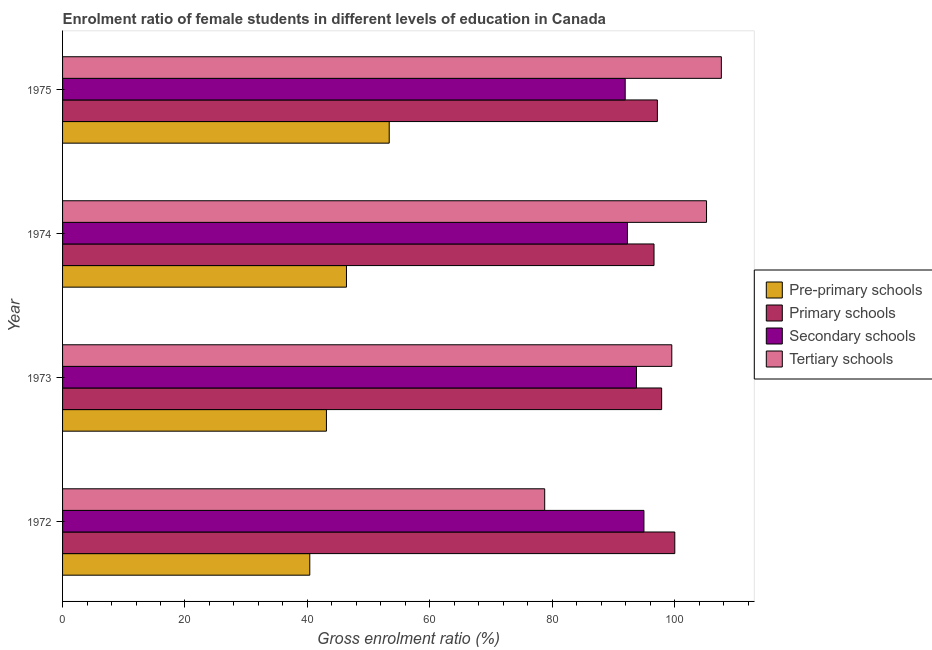Are the number of bars on each tick of the Y-axis equal?
Keep it short and to the point. Yes. How many bars are there on the 4th tick from the bottom?
Keep it short and to the point. 4. What is the label of the 1st group of bars from the top?
Provide a short and direct response. 1975. What is the gross enrolment ratio(male) in pre-primary schools in 1975?
Make the answer very short. 53.37. Across all years, what is the maximum gross enrolment ratio(male) in pre-primary schools?
Ensure brevity in your answer.  53.37. Across all years, what is the minimum gross enrolment ratio(male) in pre-primary schools?
Give a very brief answer. 40.39. In which year was the gross enrolment ratio(male) in tertiary schools maximum?
Offer a terse response. 1975. What is the total gross enrolment ratio(male) in primary schools in the graph?
Give a very brief answer. 391.71. What is the difference between the gross enrolment ratio(male) in primary schools in 1974 and that in 1975?
Ensure brevity in your answer.  -0.55. What is the difference between the gross enrolment ratio(male) in tertiary schools in 1972 and the gross enrolment ratio(male) in secondary schools in 1975?
Give a very brief answer. -13.15. What is the average gross enrolment ratio(male) in pre-primary schools per year?
Provide a short and direct response. 45.81. In the year 1974, what is the difference between the gross enrolment ratio(male) in tertiary schools and gross enrolment ratio(male) in pre-primary schools?
Make the answer very short. 58.83. What is the ratio of the gross enrolment ratio(male) in tertiary schools in 1972 to that in 1974?
Give a very brief answer. 0.75. Is the gross enrolment ratio(male) in secondary schools in 1972 less than that in 1973?
Give a very brief answer. No. Is the difference between the gross enrolment ratio(male) in tertiary schools in 1973 and 1974 greater than the difference between the gross enrolment ratio(male) in pre-primary schools in 1973 and 1974?
Provide a short and direct response. No. What is the difference between the highest and the second highest gross enrolment ratio(male) in primary schools?
Your answer should be very brief. 2.15. What is the difference between the highest and the lowest gross enrolment ratio(male) in primary schools?
Your answer should be compact. 3.39. In how many years, is the gross enrolment ratio(male) in pre-primary schools greater than the average gross enrolment ratio(male) in pre-primary schools taken over all years?
Make the answer very short. 2. Is it the case that in every year, the sum of the gross enrolment ratio(male) in pre-primary schools and gross enrolment ratio(male) in primary schools is greater than the sum of gross enrolment ratio(male) in tertiary schools and gross enrolment ratio(male) in secondary schools?
Make the answer very short. Yes. What does the 4th bar from the top in 1974 represents?
Your response must be concise. Pre-primary schools. What does the 3rd bar from the bottom in 1974 represents?
Your answer should be very brief. Secondary schools. Is it the case that in every year, the sum of the gross enrolment ratio(male) in pre-primary schools and gross enrolment ratio(male) in primary schools is greater than the gross enrolment ratio(male) in secondary schools?
Your response must be concise. Yes. How many years are there in the graph?
Your answer should be compact. 4. Are the values on the major ticks of X-axis written in scientific E-notation?
Your answer should be very brief. No. Does the graph contain any zero values?
Your answer should be very brief. No. Where does the legend appear in the graph?
Provide a short and direct response. Center right. How many legend labels are there?
Ensure brevity in your answer.  4. What is the title of the graph?
Ensure brevity in your answer.  Enrolment ratio of female students in different levels of education in Canada. Does "Minerals" appear as one of the legend labels in the graph?
Your answer should be very brief. No. What is the label or title of the X-axis?
Give a very brief answer. Gross enrolment ratio (%). What is the Gross enrolment ratio (%) in Pre-primary schools in 1972?
Make the answer very short. 40.39. What is the Gross enrolment ratio (%) of Primary schools in 1972?
Keep it short and to the point. 100.02. What is the Gross enrolment ratio (%) of Secondary schools in 1972?
Provide a succinct answer. 94.98. What is the Gross enrolment ratio (%) of Tertiary schools in 1972?
Provide a short and direct response. 78.77. What is the Gross enrolment ratio (%) of Pre-primary schools in 1973?
Give a very brief answer. 43.11. What is the Gross enrolment ratio (%) of Primary schools in 1973?
Ensure brevity in your answer.  97.88. What is the Gross enrolment ratio (%) in Secondary schools in 1973?
Make the answer very short. 93.76. What is the Gross enrolment ratio (%) of Tertiary schools in 1973?
Your response must be concise. 99.53. What is the Gross enrolment ratio (%) in Pre-primary schools in 1974?
Offer a very short reply. 46.38. What is the Gross enrolment ratio (%) of Primary schools in 1974?
Your answer should be compact. 96.63. What is the Gross enrolment ratio (%) in Secondary schools in 1974?
Your answer should be compact. 92.28. What is the Gross enrolment ratio (%) in Tertiary schools in 1974?
Offer a very short reply. 105.21. What is the Gross enrolment ratio (%) in Pre-primary schools in 1975?
Make the answer very short. 53.37. What is the Gross enrolment ratio (%) in Primary schools in 1975?
Your answer should be very brief. 97.18. What is the Gross enrolment ratio (%) in Secondary schools in 1975?
Your answer should be compact. 91.92. What is the Gross enrolment ratio (%) of Tertiary schools in 1975?
Provide a succinct answer. 107.63. Across all years, what is the maximum Gross enrolment ratio (%) of Pre-primary schools?
Provide a short and direct response. 53.37. Across all years, what is the maximum Gross enrolment ratio (%) of Primary schools?
Provide a succinct answer. 100.02. Across all years, what is the maximum Gross enrolment ratio (%) of Secondary schools?
Provide a short and direct response. 94.98. Across all years, what is the maximum Gross enrolment ratio (%) in Tertiary schools?
Keep it short and to the point. 107.63. Across all years, what is the minimum Gross enrolment ratio (%) in Pre-primary schools?
Your answer should be very brief. 40.39. Across all years, what is the minimum Gross enrolment ratio (%) in Primary schools?
Ensure brevity in your answer.  96.63. Across all years, what is the minimum Gross enrolment ratio (%) in Secondary schools?
Ensure brevity in your answer.  91.92. Across all years, what is the minimum Gross enrolment ratio (%) in Tertiary schools?
Give a very brief answer. 78.77. What is the total Gross enrolment ratio (%) in Pre-primary schools in the graph?
Provide a short and direct response. 183.25. What is the total Gross enrolment ratio (%) of Primary schools in the graph?
Make the answer very short. 391.71. What is the total Gross enrolment ratio (%) in Secondary schools in the graph?
Keep it short and to the point. 372.95. What is the total Gross enrolment ratio (%) of Tertiary schools in the graph?
Keep it short and to the point. 391.14. What is the difference between the Gross enrolment ratio (%) of Pre-primary schools in 1972 and that in 1973?
Offer a terse response. -2.72. What is the difference between the Gross enrolment ratio (%) of Primary schools in 1972 and that in 1973?
Keep it short and to the point. 2.15. What is the difference between the Gross enrolment ratio (%) of Secondary schools in 1972 and that in 1973?
Provide a short and direct response. 1.22. What is the difference between the Gross enrolment ratio (%) of Tertiary schools in 1972 and that in 1973?
Your answer should be very brief. -20.76. What is the difference between the Gross enrolment ratio (%) in Pre-primary schools in 1972 and that in 1974?
Keep it short and to the point. -5.99. What is the difference between the Gross enrolment ratio (%) of Primary schools in 1972 and that in 1974?
Your answer should be very brief. 3.39. What is the difference between the Gross enrolment ratio (%) of Secondary schools in 1972 and that in 1974?
Offer a terse response. 2.7. What is the difference between the Gross enrolment ratio (%) in Tertiary schools in 1972 and that in 1974?
Your answer should be compact. -26.44. What is the difference between the Gross enrolment ratio (%) of Pre-primary schools in 1972 and that in 1975?
Keep it short and to the point. -12.98. What is the difference between the Gross enrolment ratio (%) in Primary schools in 1972 and that in 1975?
Provide a succinct answer. 2.85. What is the difference between the Gross enrolment ratio (%) of Secondary schools in 1972 and that in 1975?
Provide a succinct answer. 3.06. What is the difference between the Gross enrolment ratio (%) in Tertiary schools in 1972 and that in 1975?
Your response must be concise. -28.86. What is the difference between the Gross enrolment ratio (%) in Pre-primary schools in 1973 and that in 1974?
Make the answer very short. -3.27. What is the difference between the Gross enrolment ratio (%) in Primary schools in 1973 and that in 1974?
Offer a terse response. 1.25. What is the difference between the Gross enrolment ratio (%) of Secondary schools in 1973 and that in 1974?
Provide a succinct answer. 1.48. What is the difference between the Gross enrolment ratio (%) in Tertiary schools in 1973 and that in 1974?
Ensure brevity in your answer.  -5.68. What is the difference between the Gross enrolment ratio (%) in Pre-primary schools in 1973 and that in 1975?
Ensure brevity in your answer.  -10.26. What is the difference between the Gross enrolment ratio (%) in Primary schools in 1973 and that in 1975?
Keep it short and to the point. 0.7. What is the difference between the Gross enrolment ratio (%) of Secondary schools in 1973 and that in 1975?
Make the answer very short. 1.84. What is the difference between the Gross enrolment ratio (%) in Tertiary schools in 1973 and that in 1975?
Keep it short and to the point. -8.1. What is the difference between the Gross enrolment ratio (%) in Pre-primary schools in 1974 and that in 1975?
Your answer should be very brief. -6.98. What is the difference between the Gross enrolment ratio (%) in Primary schools in 1974 and that in 1975?
Make the answer very short. -0.55. What is the difference between the Gross enrolment ratio (%) of Secondary schools in 1974 and that in 1975?
Ensure brevity in your answer.  0.36. What is the difference between the Gross enrolment ratio (%) of Tertiary schools in 1974 and that in 1975?
Make the answer very short. -2.42. What is the difference between the Gross enrolment ratio (%) in Pre-primary schools in 1972 and the Gross enrolment ratio (%) in Primary schools in 1973?
Your response must be concise. -57.49. What is the difference between the Gross enrolment ratio (%) in Pre-primary schools in 1972 and the Gross enrolment ratio (%) in Secondary schools in 1973?
Give a very brief answer. -53.37. What is the difference between the Gross enrolment ratio (%) of Pre-primary schools in 1972 and the Gross enrolment ratio (%) of Tertiary schools in 1973?
Offer a very short reply. -59.14. What is the difference between the Gross enrolment ratio (%) of Primary schools in 1972 and the Gross enrolment ratio (%) of Secondary schools in 1973?
Offer a terse response. 6.26. What is the difference between the Gross enrolment ratio (%) of Primary schools in 1972 and the Gross enrolment ratio (%) of Tertiary schools in 1973?
Ensure brevity in your answer.  0.49. What is the difference between the Gross enrolment ratio (%) of Secondary schools in 1972 and the Gross enrolment ratio (%) of Tertiary schools in 1973?
Offer a terse response. -4.55. What is the difference between the Gross enrolment ratio (%) in Pre-primary schools in 1972 and the Gross enrolment ratio (%) in Primary schools in 1974?
Offer a very short reply. -56.24. What is the difference between the Gross enrolment ratio (%) of Pre-primary schools in 1972 and the Gross enrolment ratio (%) of Secondary schools in 1974?
Offer a very short reply. -51.89. What is the difference between the Gross enrolment ratio (%) of Pre-primary schools in 1972 and the Gross enrolment ratio (%) of Tertiary schools in 1974?
Your response must be concise. -64.82. What is the difference between the Gross enrolment ratio (%) in Primary schools in 1972 and the Gross enrolment ratio (%) in Secondary schools in 1974?
Keep it short and to the point. 7.74. What is the difference between the Gross enrolment ratio (%) of Primary schools in 1972 and the Gross enrolment ratio (%) of Tertiary schools in 1974?
Offer a terse response. -5.18. What is the difference between the Gross enrolment ratio (%) of Secondary schools in 1972 and the Gross enrolment ratio (%) of Tertiary schools in 1974?
Your response must be concise. -10.23. What is the difference between the Gross enrolment ratio (%) in Pre-primary schools in 1972 and the Gross enrolment ratio (%) in Primary schools in 1975?
Keep it short and to the point. -56.79. What is the difference between the Gross enrolment ratio (%) in Pre-primary schools in 1972 and the Gross enrolment ratio (%) in Secondary schools in 1975?
Your answer should be compact. -51.53. What is the difference between the Gross enrolment ratio (%) of Pre-primary schools in 1972 and the Gross enrolment ratio (%) of Tertiary schools in 1975?
Provide a short and direct response. -67.24. What is the difference between the Gross enrolment ratio (%) in Primary schools in 1972 and the Gross enrolment ratio (%) in Secondary schools in 1975?
Offer a very short reply. 8.1. What is the difference between the Gross enrolment ratio (%) of Primary schools in 1972 and the Gross enrolment ratio (%) of Tertiary schools in 1975?
Keep it short and to the point. -7.61. What is the difference between the Gross enrolment ratio (%) of Secondary schools in 1972 and the Gross enrolment ratio (%) of Tertiary schools in 1975?
Your answer should be very brief. -12.65. What is the difference between the Gross enrolment ratio (%) of Pre-primary schools in 1973 and the Gross enrolment ratio (%) of Primary schools in 1974?
Your answer should be very brief. -53.52. What is the difference between the Gross enrolment ratio (%) of Pre-primary schools in 1973 and the Gross enrolment ratio (%) of Secondary schools in 1974?
Make the answer very short. -49.17. What is the difference between the Gross enrolment ratio (%) of Pre-primary schools in 1973 and the Gross enrolment ratio (%) of Tertiary schools in 1974?
Your answer should be very brief. -62.1. What is the difference between the Gross enrolment ratio (%) of Primary schools in 1973 and the Gross enrolment ratio (%) of Secondary schools in 1974?
Ensure brevity in your answer.  5.59. What is the difference between the Gross enrolment ratio (%) in Primary schools in 1973 and the Gross enrolment ratio (%) in Tertiary schools in 1974?
Your answer should be very brief. -7.33. What is the difference between the Gross enrolment ratio (%) in Secondary schools in 1973 and the Gross enrolment ratio (%) in Tertiary schools in 1974?
Your response must be concise. -11.45. What is the difference between the Gross enrolment ratio (%) in Pre-primary schools in 1973 and the Gross enrolment ratio (%) in Primary schools in 1975?
Provide a short and direct response. -54.07. What is the difference between the Gross enrolment ratio (%) in Pre-primary schools in 1973 and the Gross enrolment ratio (%) in Secondary schools in 1975?
Your answer should be compact. -48.81. What is the difference between the Gross enrolment ratio (%) in Pre-primary schools in 1973 and the Gross enrolment ratio (%) in Tertiary schools in 1975?
Offer a terse response. -64.52. What is the difference between the Gross enrolment ratio (%) in Primary schools in 1973 and the Gross enrolment ratio (%) in Secondary schools in 1975?
Offer a terse response. 5.95. What is the difference between the Gross enrolment ratio (%) of Primary schools in 1973 and the Gross enrolment ratio (%) of Tertiary schools in 1975?
Ensure brevity in your answer.  -9.75. What is the difference between the Gross enrolment ratio (%) of Secondary schools in 1973 and the Gross enrolment ratio (%) of Tertiary schools in 1975?
Ensure brevity in your answer.  -13.87. What is the difference between the Gross enrolment ratio (%) of Pre-primary schools in 1974 and the Gross enrolment ratio (%) of Primary schools in 1975?
Your answer should be very brief. -50.79. What is the difference between the Gross enrolment ratio (%) in Pre-primary schools in 1974 and the Gross enrolment ratio (%) in Secondary schools in 1975?
Provide a short and direct response. -45.54. What is the difference between the Gross enrolment ratio (%) of Pre-primary schools in 1974 and the Gross enrolment ratio (%) of Tertiary schools in 1975?
Your answer should be compact. -61.25. What is the difference between the Gross enrolment ratio (%) of Primary schools in 1974 and the Gross enrolment ratio (%) of Secondary schools in 1975?
Your answer should be very brief. 4.71. What is the difference between the Gross enrolment ratio (%) in Primary schools in 1974 and the Gross enrolment ratio (%) in Tertiary schools in 1975?
Make the answer very short. -11. What is the difference between the Gross enrolment ratio (%) of Secondary schools in 1974 and the Gross enrolment ratio (%) of Tertiary schools in 1975?
Offer a very short reply. -15.35. What is the average Gross enrolment ratio (%) in Pre-primary schools per year?
Your answer should be compact. 45.81. What is the average Gross enrolment ratio (%) of Primary schools per year?
Provide a succinct answer. 97.93. What is the average Gross enrolment ratio (%) of Secondary schools per year?
Offer a very short reply. 93.24. What is the average Gross enrolment ratio (%) of Tertiary schools per year?
Your answer should be very brief. 97.79. In the year 1972, what is the difference between the Gross enrolment ratio (%) in Pre-primary schools and Gross enrolment ratio (%) in Primary schools?
Give a very brief answer. -59.63. In the year 1972, what is the difference between the Gross enrolment ratio (%) in Pre-primary schools and Gross enrolment ratio (%) in Secondary schools?
Offer a terse response. -54.59. In the year 1972, what is the difference between the Gross enrolment ratio (%) of Pre-primary schools and Gross enrolment ratio (%) of Tertiary schools?
Give a very brief answer. -38.38. In the year 1972, what is the difference between the Gross enrolment ratio (%) in Primary schools and Gross enrolment ratio (%) in Secondary schools?
Offer a very short reply. 5.04. In the year 1972, what is the difference between the Gross enrolment ratio (%) in Primary schools and Gross enrolment ratio (%) in Tertiary schools?
Offer a very short reply. 21.26. In the year 1972, what is the difference between the Gross enrolment ratio (%) of Secondary schools and Gross enrolment ratio (%) of Tertiary schools?
Offer a very short reply. 16.21. In the year 1973, what is the difference between the Gross enrolment ratio (%) in Pre-primary schools and Gross enrolment ratio (%) in Primary schools?
Make the answer very short. -54.77. In the year 1973, what is the difference between the Gross enrolment ratio (%) of Pre-primary schools and Gross enrolment ratio (%) of Secondary schools?
Offer a very short reply. -50.65. In the year 1973, what is the difference between the Gross enrolment ratio (%) in Pre-primary schools and Gross enrolment ratio (%) in Tertiary schools?
Ensure brevity in your answer.  -56.42. In the year 1973, what is the difference between the Gross enrolment ratio (%) of Primary schools and Gross enrolment ratio (%) of Secondary schools?
Ensure brevity in your answer.  4.11. In the year 1973, what is the difference between the Gross enrolment ratio (%) in Primary schools and Gross enrolment ratio (%) in Tertiary schools?
Provide a succinct answer. -1.66. In the year 1973, what is the difference between the Gross enrolment ratio (%) of Secondary schools and Gross enrolment ratio (%) of Tertiary schools?
Offer a very short reply. -5.77. In the year 1974, what is the difference between the Gross enrolment ratio (%) in Pre-primary schools and Gross enrolment ratio (%) in Primary schools?
Your response must be concise. -50.25. In the year 1974, what is the difference between the Gross enrolment ratio (%) in Pre-primary schools and Gross enrolment ratio (%) in Secondary schools?
Keep it short and to the point. -45.9. In the year 1974, what is the difference between the Gross enrolment ratio (%) of Pre-primary schools and Gross enrolment ratio (%) of Tertiary schools?
Give a very brief answer. -58.83. In the year 1974, what is the difference between the Gross enrolment ratio (%) in Primary schools and Gross enrolment ratio (%) in Secondary schools?
Your response must be concise. 4.35. In the year 1974, what is the difference between the Gross enrolment ratio (%) in Primary schools and Gross enrolment ratio (%) in Tertiary schools?
Your answer should be compact. -8.58. In the year 1974, what is the difference between the Gross enrolment ratio (%) in Secondary schools and Gross enrolment ratio (%) in Tertiary schools?
Provide a succinct answer. -12.93. In the year 1975, what is the difference between the Gross enrolment ratio (%) of Pre-primary schools and Gross enrolment ratio (%) of Primary schools?
Keep it short and to the point. -43.81. In the year 1975, what is the difference between the Gross enrolment ratio (%) of Pre-primary schools and Gross enrolment ratio (%) of Secondary schools?
Make the answer very short. -38.56. In the year 1975, what is the difference between the Gross enrolment ratio (%) in Pre-primary schools and Gross enrolment ratio (%) in Tertiary schools?
Make the answer very short. -54.26. In the year 1975, what is the difference between the Gross enrolment ratio (%) in Primary schools and Gross enrolment ratio (%) in Secondary schools?
Provide a succinct answer. 5.25. In the year 1975, what is the difference between the Gross enrolment ratio (%) in Primary schools and Gross enrolment ratio (%) in Tertiary schools?
Offer a terse response. -10.45. In the year 1975, what is the difference between the Gross enrolment ratio (%) of Secondary schools and Gross enrolment ratio (%) of Tertiary schools?
Ensure brevity in your answer.  -15.71. What is the ratio of the Gross enrolment ratio (%) of Pre-primary schools in 1972 to that in 1973?
Give a very brief answer. 0.94. What is the ratio of the Gross enrolment ratio (%) of Secondary schools in 1972 to that in 1973?
Give a very brief answer. 1.01. What is the ratio of the Gross enrolment ratio (%) in Tertiary schools in 1972 to that in 1973?
Keep it short and to the point. 0.79. What is the ratio of the Gross enrolment ratio (%) of Pre-primary schools in 1972 to that in 1974?
Your response must be concise. 0.87. What is the ratio of the Gross enrolment ratio (%) of Primary schools in 1972 to that in 1974?
Provide a short and direct response. 1.04. What is the ratio of the Gross enrolment ratio (%) in Secondary schools in 1972 to that in 1974?
Offer a terse response. 1.03. What is the ratio of the Gross enrolment ratio (%) in Tertiary schools in 1972 to that in 1974?
Provide a short and direct response. 0.75. What is the ratio of the Gross enrolment ratio (%) of Pre-primary schools in 1972 to that in 1975?
Keep it short and to the point. 0.76. What is the ratio of the Gross enrolment ratio (%) in Primary schools in 1972 to that in 1975?
Keep it short and to the point. 1.03. What is the ratio of the Gross enrolment ratio (%) of Tertiary schools in 1972 to that in 1975?
Keep it short and to the point. 0.73. What is the ratio of the Gross enrolment ratio (%) in Pre-primary schools in 1973 to that in 1974?
Offer a very short reply. 0.93. What is the ratio of the Gross enrolment ratio (%) in Primary schools in 1973 to that in 1974?
Offer a very short reply. 1.01. What is the ratio of the Gross enrolment ratio (%) in Secondary schools in 1973 to that in 1974?
Offer a terse response. 1.02. What is the ratio of the Gross enrolment ratio (%) of Tertiary schools in 1973 to that in 1974?
Provide a succinct answer. 0.95. What is the ratio of the Gross enrolment ratio (%) of Pre-primary schools in 1973 to that in 1975?
Provide a short and direct response. 0.81. What is the ratio of the Gross enrolment ratio (%) of Secondary schools in 1973 to that in 1975?
Provide a short and direct response. 1.02. What is the ratio of the Gross enrolment ratio (%) of Tertiary schools in 1973 to that in 1975?
Ensure brevity in your answer.  0.92. What is the ratio of the Gross enrolment ratio (%) of Pre-primary schools in 1974 to that in 1975?
Keep it short and to the point. 0.87. What is the ratio of the Gross enrolment ratio (%) of Primary schools in 1974 to that in 1975?
Your answer should be compact. 0.99. What is the ratio of the Gross enrolment ratio (%) of Tertiary schools in 1974 to that in 1975?
Keep it short and to the point. 0.98. What is the difference between the highest and the second highest Gross enrolment ratio (%) in Pre-primary schools?
Keep it short and to the point. 6.98. What is the difference between the highest and the second highest Gross enrolment ratio (%) in Primary schools?
Give a very brief answer. 2.15. What is the difference between the highest and the second highest Gross enrolment ratio (%) of Secondary schools?
Make the answer very short. 1.22. What is the difference between the highest and the second highest Gross enrolment ratio (%) in Tertiary schools?
Your response must be concise. 2.42. What is the difference between the highest and the lowest Gross enrolment ratio (%) in Pre-primary schools?
Give a very brief answer. 12.98. What is the difference between the highest and the lowest Gross enrolment ratio (%) in Primary schools?
Your answer should be very brief. 3.39. What is the difference between the highest and the lowest Gross enrolment ratio (%) of Secondary schools?
Offer a terse response. 3.06. What is the difference between the highest and the lowest Gross enrolment ratio (%) in Tertiary schools?
Your answer should be compact. 28.86. 